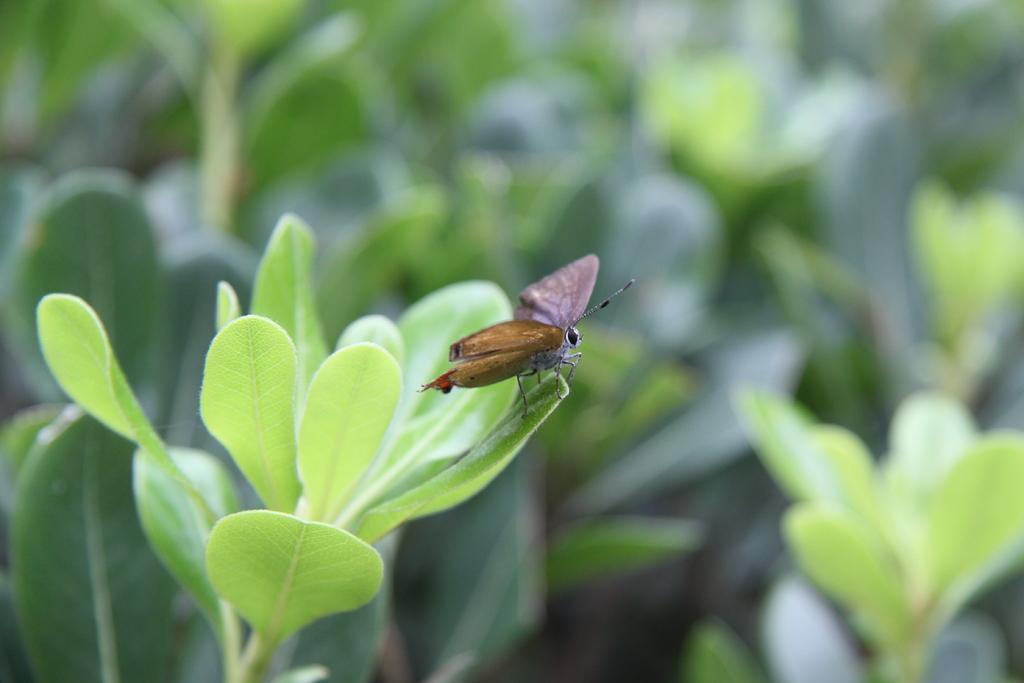How would you summarize this image in a sentence or two? In the picture we can see a plants with a leaves on it we can see a moth with wings, legs and antenna. 